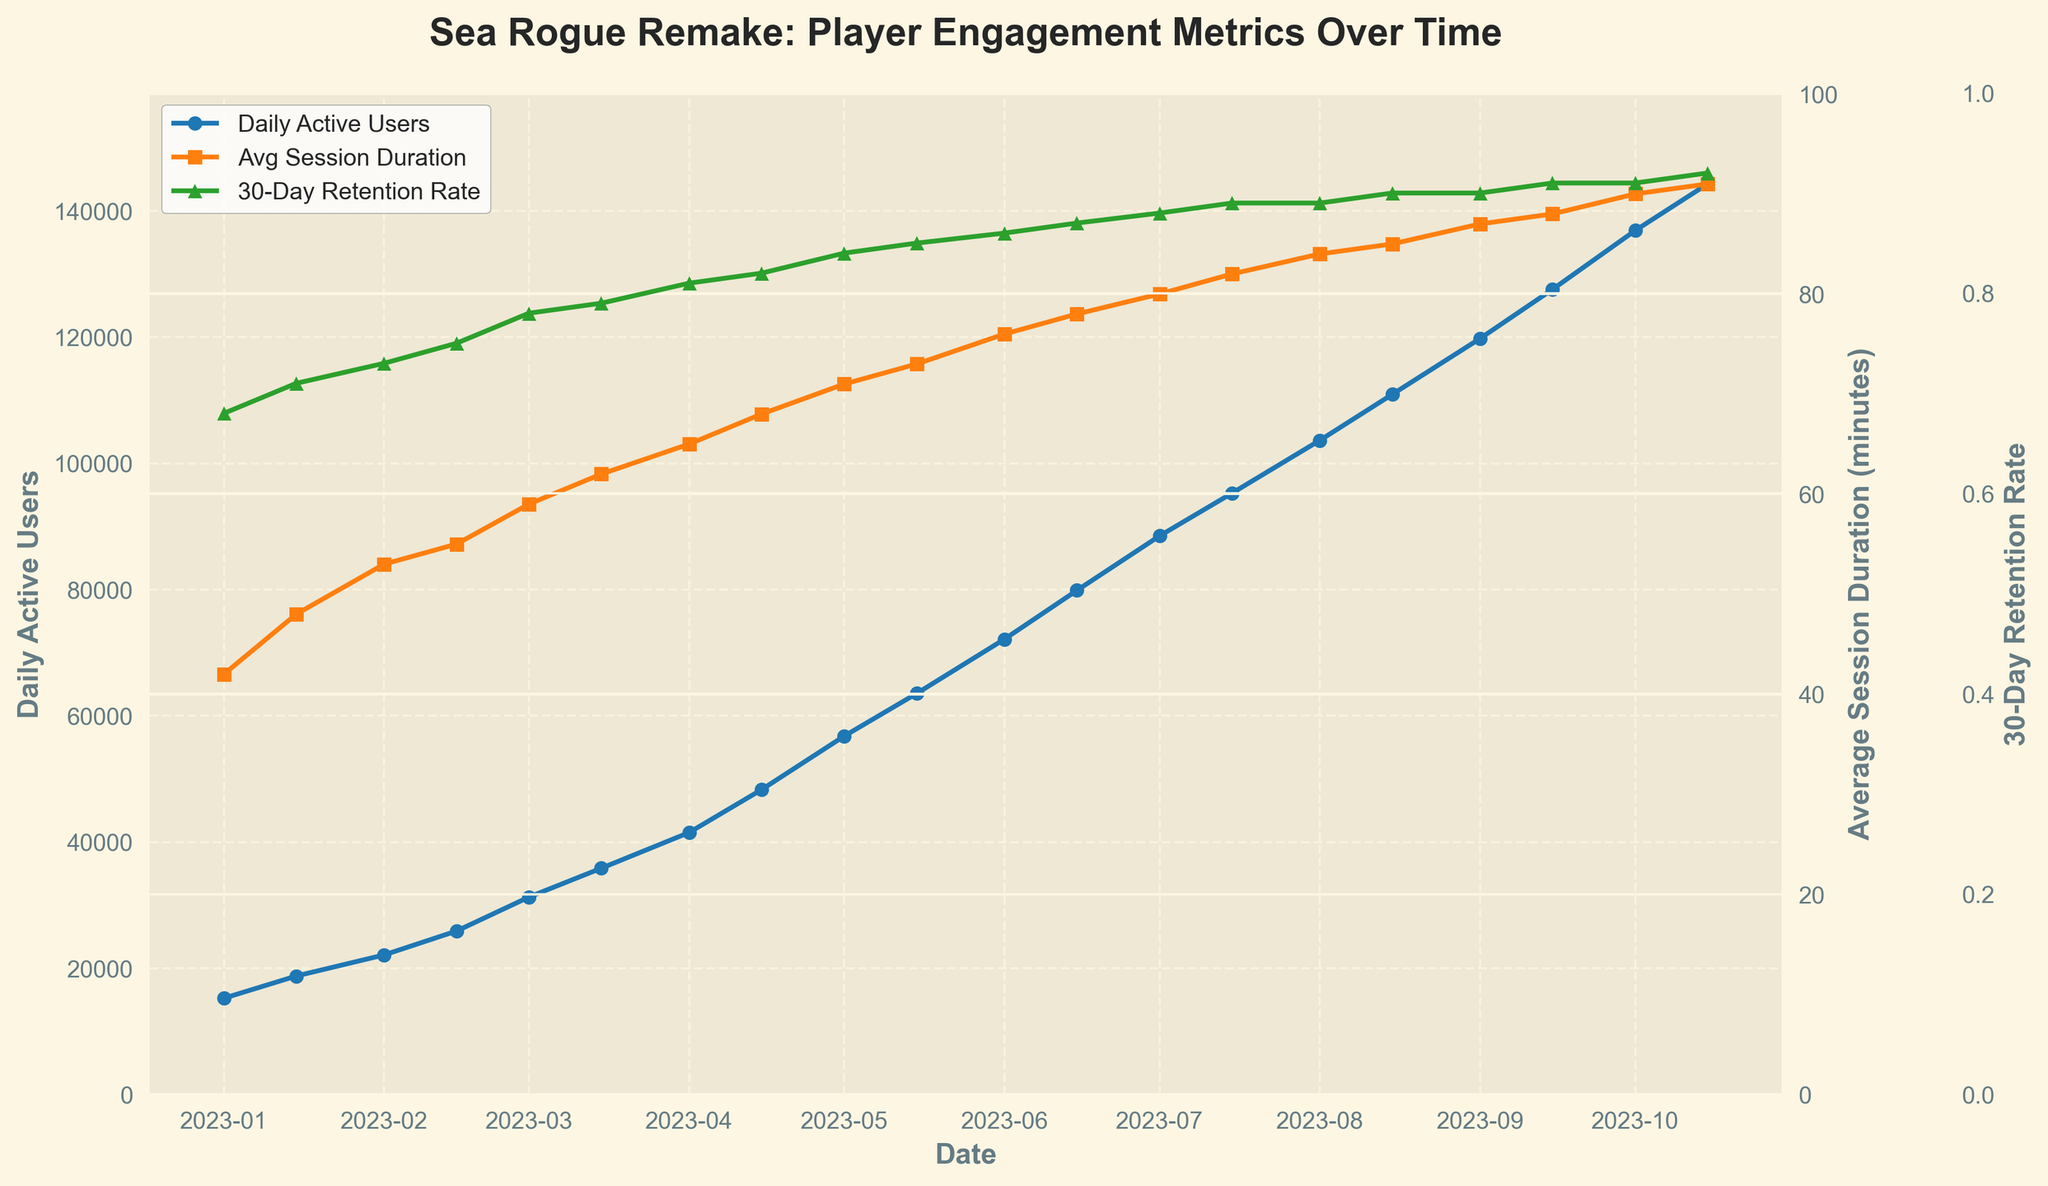What date has the highest number of daily active users? By looking at the figure, identify the date where the blue line (Daily Active Users) reaches its peak.
Answer: 2023-10-15 Which metric shows the steepest increase during the first half of 2023 and how do you know? Compare the slopes of the lines for the three metrics from January 2023 to June 2023. The metric with the steepest slope should show the largest change over this period.
Answer: Daily Active Users; they increased from ~15,243 in January to ~87,145 in June What is the average session duration on July 15, 2023? Locate the orange line (Average Session Duration) on the date July 15, 2023, and read the corresponding value.
Answer: 82 minutes How has the 30-day retention rate changed from January 1, 2023, to October 15, 2023? Compare the green line's value on January 1, 2023, and on October 15, 2023, to observe the change.
Answer: It increased from 0.68 to 0.92 By how many users did Daily Active Users increase from June 1, 2023, to October 1, 2023? Subtract the number of Daily Active Users on June 1, 2023, from the number on October 1, 2023 (119,784 - 72,145).
Answer: 47,639 Which date has the highest average session duration and what is the value? Look for the highest point on the orange line and match it to the date.
Answer: 2023-10-15; 91 minutes Is there any period where the 30-day retention rate remains constant? If so, which period? Examine the green line to see if it flattens out at any point, indicating constancy.
Answer: Yes, between August 1, 2023, and September 1, 2023 What is the relationship between Daily Active Users and the 30-Day Retention Rate between April 1, 2023, and October 15, 2023? Compare the trends of blue and green lines from April 1, 2023, to October 15, 2023. Both lines show an upwards trend during this period.
Answer: Both increase over time Describe the trend of Average Session Duration from January 2023 to October 2023 using the visual information. Look at the orange line's trajectory from January to October. Indicate the general direction (upwards, downwards) and any noticeable changes in the slope.
Answer: The trend is upward, showing a steady increase from 42 to 91 minutes What is the difference in 30-day retention rate between February 1, 2023, and March 1, 2023? Locate the 30-day retention rate values for these two dates on the green line and subtract the February 1 value from the March 1 value (0.78 - 0.73).
Answer: 0.05 